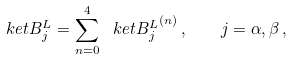Convert formula to latex. <formula><loc_0><loc_0><loc_500><loc_500>\ k e t { B _ { j } ^ { L } } = \sum _ { n = 0 } ^ { 4 } \ k e t { B _ { j } ^ { L } } ^ { ( n ) } \, , \quad j = \alpha , \beta \, ,</formula> 